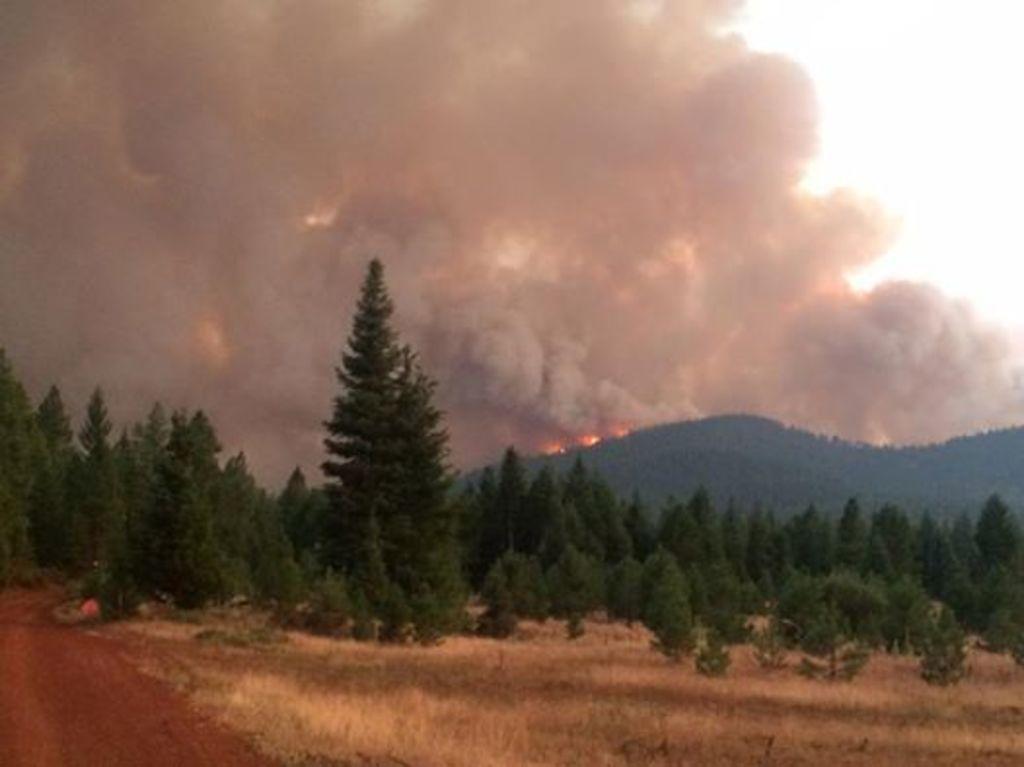Please provide a concise description of this image. In the center of the image we can see trees, hills are there. In the background of the image fire smoke is there. At the top right corner sky is there. At the bottom of the image ground is there. 